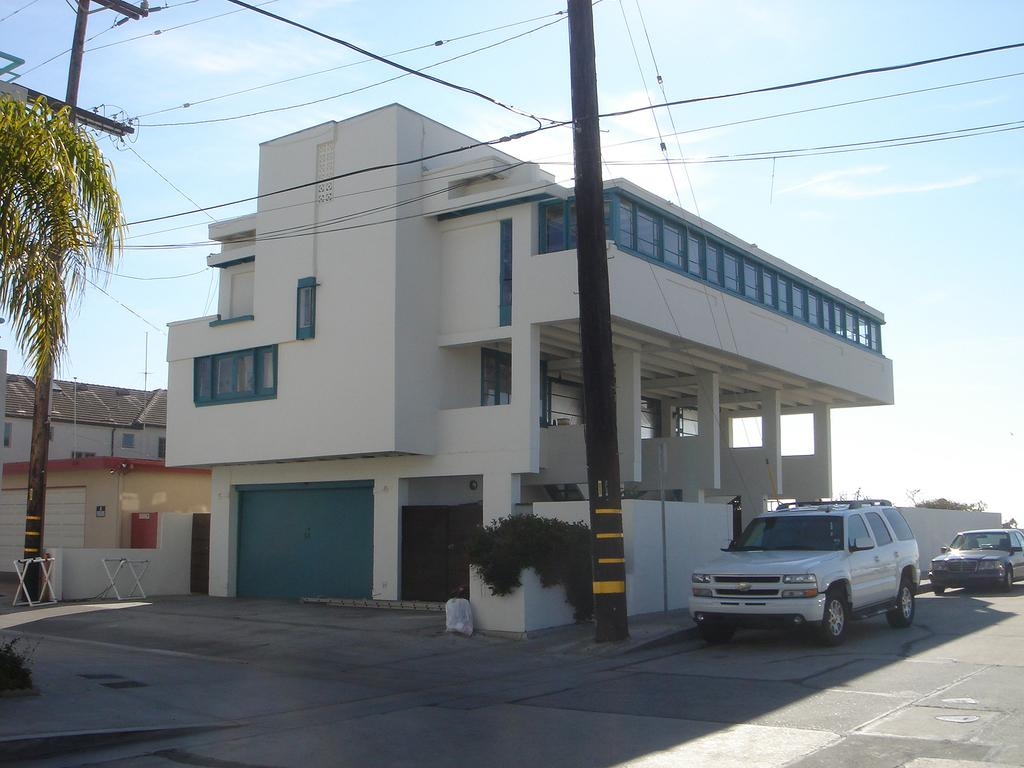What type of structures can be seen in the image? There are buildings in the image. What else can be seen near the buildings? Vehicles are parked near the buildings, and trees and utility poles are visible in front of the buildings. What is visible in the background of the image? The sky is visible in the background of the image. Can you tell me how many parents are standing next to the giants in the image? There are no parents or giants present in the image. What type of heart is visible in the image? There is no heart present in the image. 